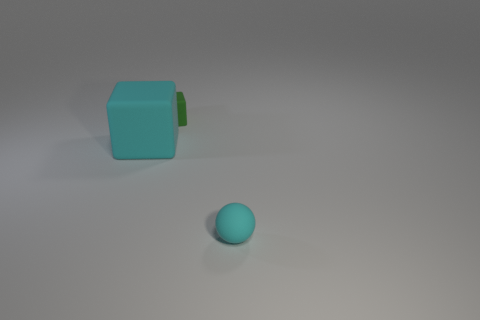Add 1 tiny cyan objects. How many objects exist? 4 Subtract all balls. How many objects are left? 2 Add 1 large cyan cubes. How many large cyan cubes are left? 2 Add 2 cyan spheres. How many cyan spheres exist? 3 Subtract 1 cyan cubes. How many objects are left? 2 Subtract all brown matte blocks. Subtract all green objects. How many objects are left? 2 